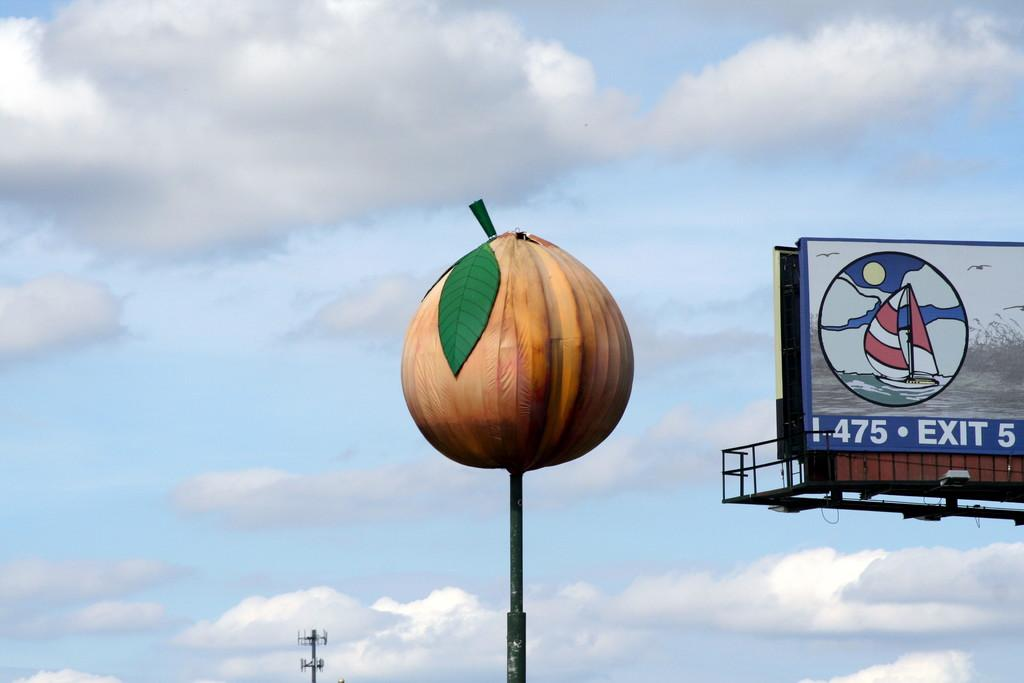What is the main object in the center of the image? There is a pole in the center of the image. What can be seen on the right side of the image? There is a hoarding on the right side of the image. What is visible in the background of the image? The sky is visible in the background of the image. What type of vest is being worn by the person in the image? There is no person present in the image, and therefore no vest can be observed. 